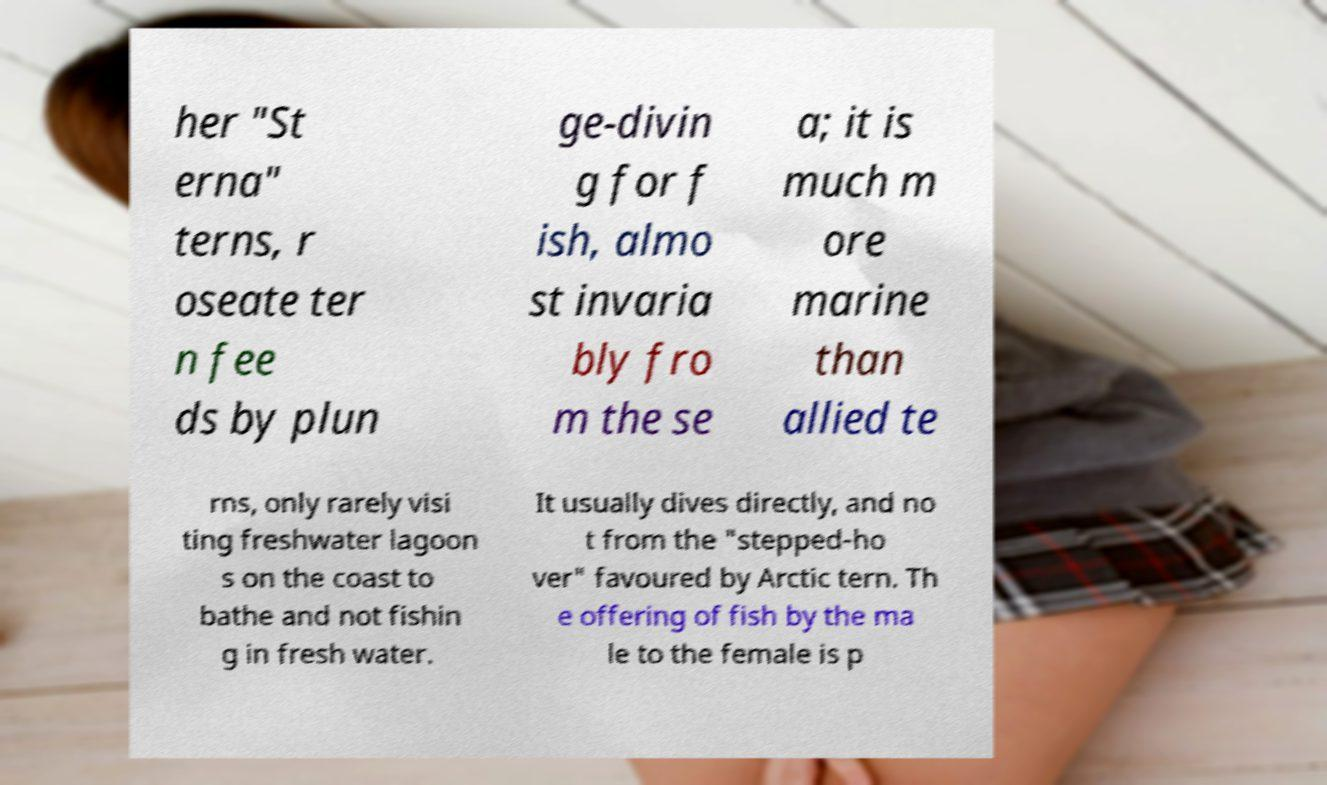What messages or text are displayed in this image? I need them in a readable, typed format. her "St erna" terns, r oseate ter n fee ds by plun ge-divin g for f ish, almo st invaria bly fro m the se a; it is much m ore marine than allied te rns, only rarely visi ting freshwater lagoon s on the coast to bathe and not fishin g in fresh water. It usually dives directly, and no t from the "stepped-ho ver" favoured by Arctic tern. Th e offering of fish by the ma le to the female is p 